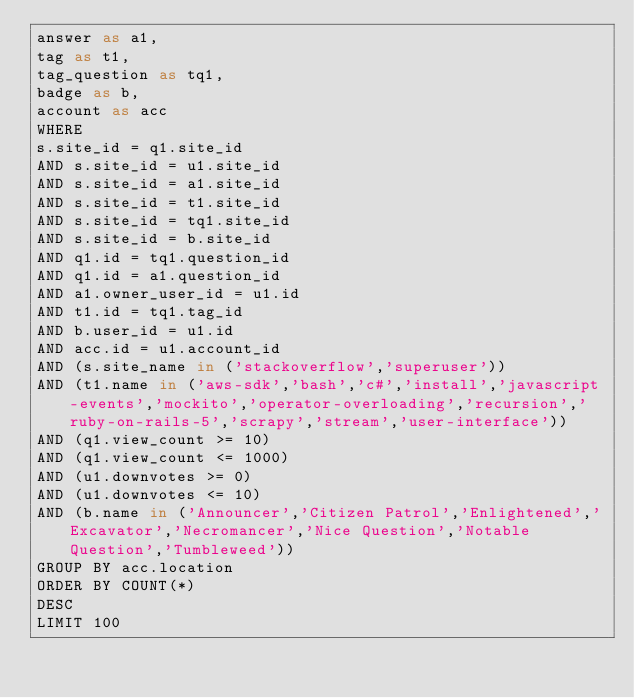<code> <loc_0><loc_0><loc_500><loc_500><_SQL_>answer as a1,
tag as t1,
tag_question as tq1,
badge as b,
account as acc
WHERE
s.site_id = q1.site_id
AND s.site_id = u1.site_id
AND s.site_id = a1.site_id
AND s.site_id = t1.site_id
AND s.site_id = tq1.site_id
AND s.site_id = b.site_id
AND q1.id = tq1.question_id
AND q1.id = a1.question_id
AND a1.owner_user_id = u1.id
AND t1.id = tq1.tag_id
AND b.user_id = u1.id
AND acc.id = u1.account_id
AND (s.site_name in ('stackoverflow','superuser'))
AND (t1.name in ('aws-sdk','bash','c#','install','javascript-events','mockito','operator-overloading','recursion','ruby-on-rails-5','scrapy','stream','user-interface'))
AND (q1.view_count >= 10)
AND (q1.view_count <= 1000)
AND (u1.downvotes >= 0)
AND (u1.downvotes <= 10)
AND (b.name in ('Announcer','Citizen Patrol','Enlightened','Excavator','Necromancer','Nice Question','Notable Question','Tumbleweed'))
GROUP BY acc.location
ORDER BY COUNT(*)
DESC
LIMIT 100
</code> 